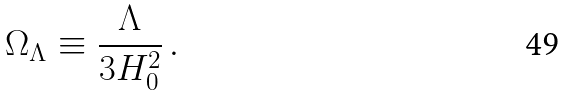<formula> <loc_0><loc_0><loc_500><loc_500>\Omega _ { \Lambda } \equiv \frac { \Lambda } { 3 H _ { 0 } ^ { 2 } } \, .</formula> 